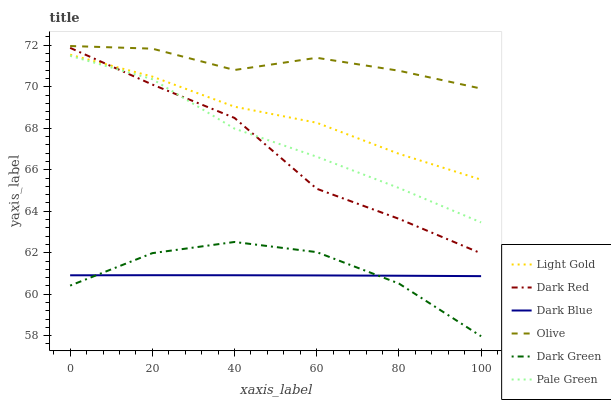Does Dark Blue have the minimum area under the curve?
Answer yes or no. Yes. Does Olive have the maximum area under the curve?
Answer yes or no. Yes. Does Pale Green have the minimum area under the curve?
Answer yes or no. No. Does Pale Green have the maximum area under the curve?
Answer yes or no. No. Is Dark Blue the smoothest?
Answer yes or no. Yes. Is Dark Red the roughest?
Answer yes or no. Yes. Is Pale Green the smoothest?
Answer yes or no. No. Is Pale Green the roughest?
Answer yes or no. No. Does Dark Green have the lowest value?
Answer yes or no. Yes. Does Dark Blue have the lowest value?
Answer yes or no. No. Does Olive have the highest value?
Answer yes or no. Yes. Does Pale Green have the highest value?
Answer yes or no. No. Is Light Gold less than Olive?
Answer yes or no. Yes. Is Dark Red greater than Dark Green?
Answer yes or no. Yes. Does Dark Blue intersect Dark Green?
Answer yes or no. Yes. Is Dark Blue less than Dark Green?
Answer yes or no. No. Is Dark Blue greater than Dark Green?
Answer yes or no. No. Does Light Gold intersect Olive?
Answer yes or no. No. 